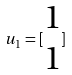Convert formula to latex. <formula><loc_0><loc_0><loc_500><loc_500>u _ { 1 } = [ \begin{matrix} 1 \\ 1 \end{matrix} ]</formula> 